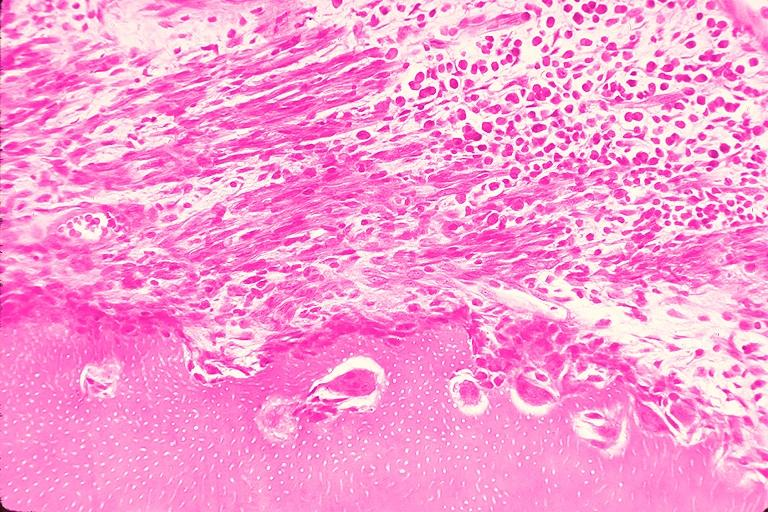what does this image show?
Answer the question using a single word or phrase. Resorption 